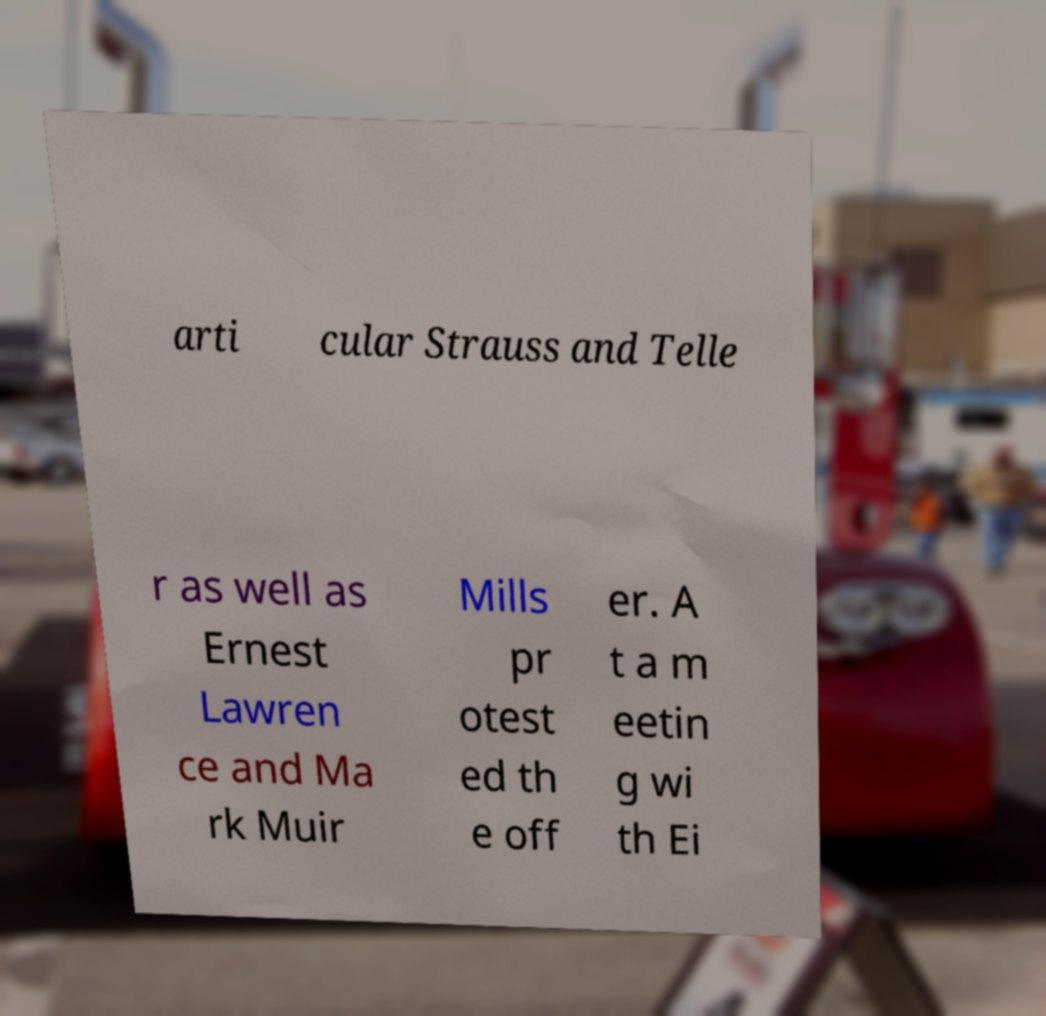What messages or text are displayed in this image? I need them in a readable, typed format. arti cular Strauss and Telle r as well as Ernest Lawren ce and Ma rk Muir Mills pr otest ed th e off er. A t a m eetin g wi th Ei 